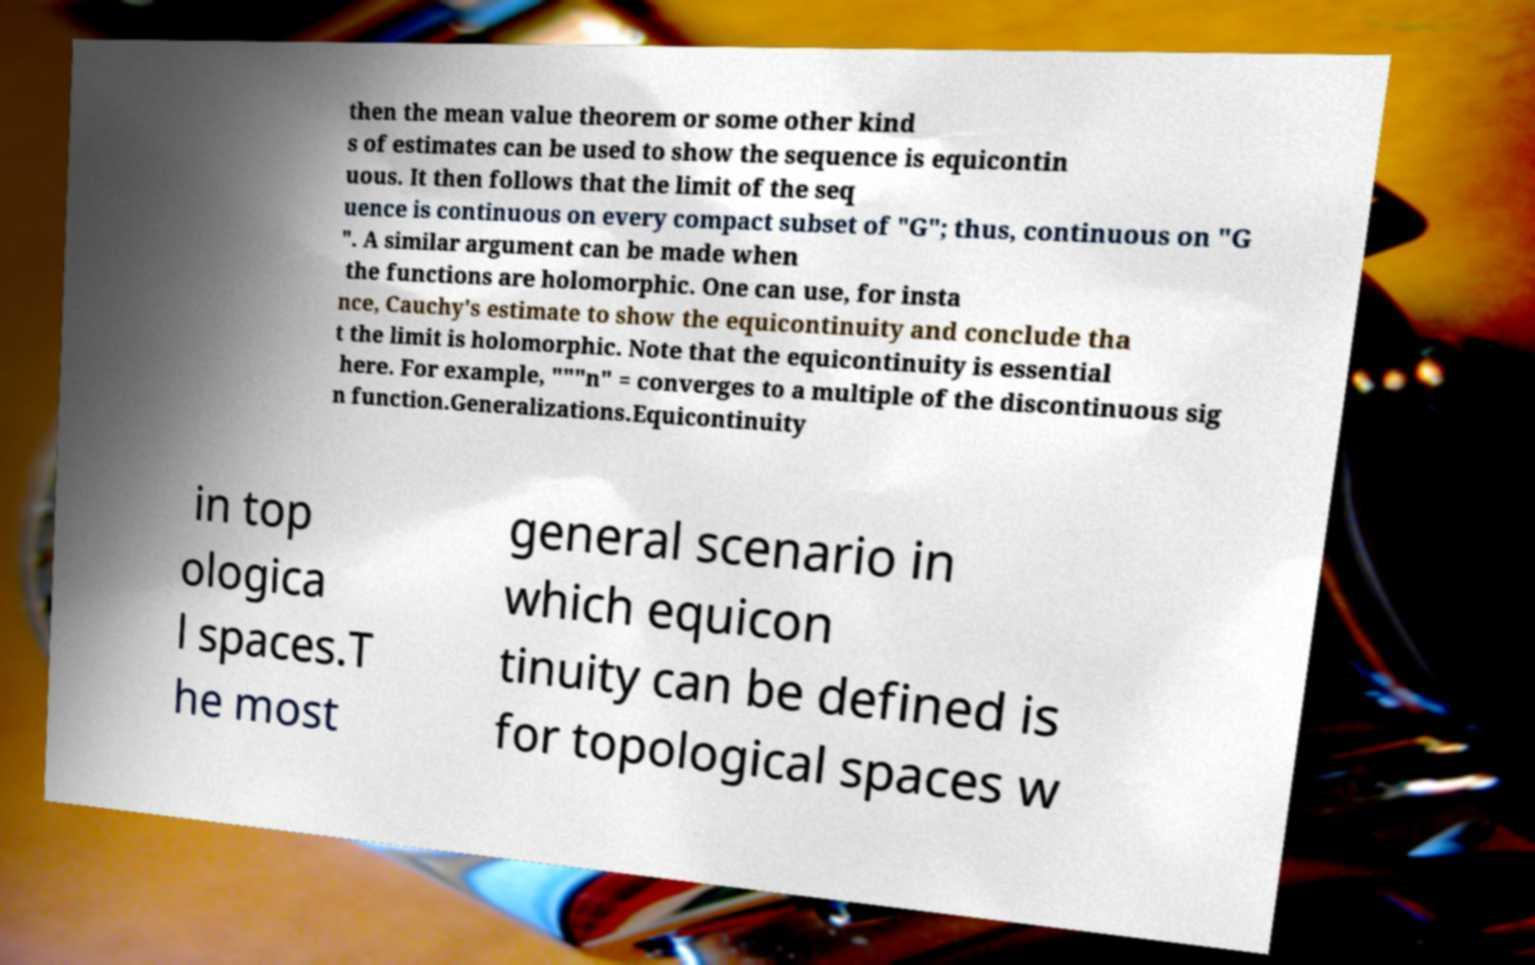Could you extract and type out the text from this image? then the mean value theorem or some other kind s of estimates can be used to show the sequence is equicontin uous. It then follows that the limit of the seq uence is continuous on every compact subset of "G"; thus, continuous on "G ". A similar argument can be made when the functions are holomorphic. One can use, for insta nce, Cauchy's estimate to show the equicontinuity and conclude tha t the limit is holomorphic. Note that the equicontinuity is essential here. For example, """n" = converges to a multiple of the discontinuous sig n function.Generalizations.Equicontinuity in top ologica l spaces.T he most general scenario in which equicon tinuity can be defined is for topological spaces w 